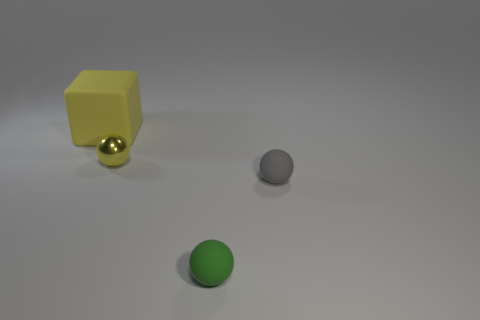What number of cubes are either tiny yellow objects or matte things? In the image, there is one cube which is yellow in color and appears to be matte rather than shiny. Therefore, there is one cube that fits the criteria of being a tiny, yellow object or a matte thing. 